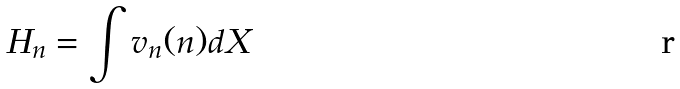<formula> <loc_0><loc_0><loc_500><loc_500>H _ { n } = \int v _ { n } ( n ) d X</formula> 